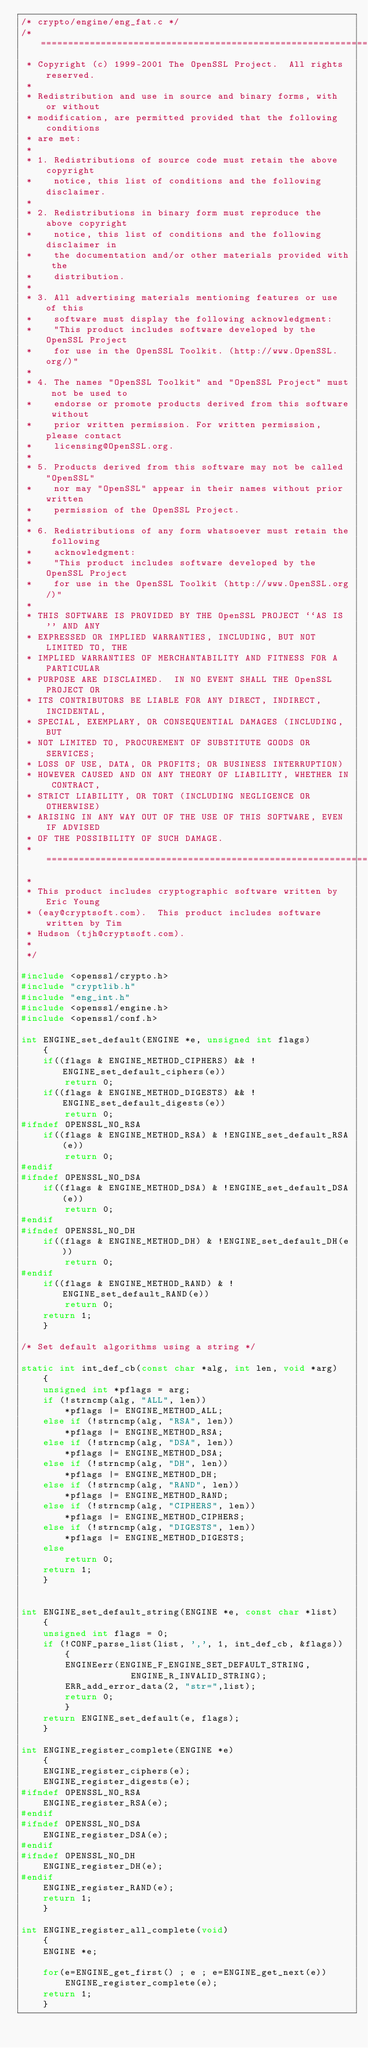Convert code to text. <code><loc_0><loc_0><loc_500><loc_500><_C_>/* crypto/engine/eng_fat.c */
/* ====================================================================
 * Copyright (c) 1999-2001 The OpenSSL Project.  All rights reserved.
 *
 * Redistribution and use in source and binary forms, with or without
 * modification, are permitted provided that the following conditions
 * are met:
 *
 * 1. Redistributions of source code must retain the above copyright
 *    notice, this list of conditions and the following disclaimer. 
 *
 * 2. Redistributions in binary form must reproduce the above copyright
 *    notice, this list of conditions and the following disclaimer in
 *    the documentation and/or other materials provided with the
 *    distribution.
 *
 * 3. All advertising materials mentioning features or use of this
 *    software must display the following acknowledgment:
 *    "This product includes software developed by the OpenSSL Project
 *    for use in the OpenSSL Toolkit. (http://www.OpenSSL.org/)"
 *
 * 4. The names "OpenSSL Toolkit" and "OpenSSL Project" must not be used to
 *    endorse or promote products derived from this software without
 *    prior written permission. For written permission, please contact
 *    licensing@OpenSSL.org.
 *
 * 5. Products derived from this software may not be called "OpenSSL"
 *    nor may "OpenSSL" appear in their names without prior written
 *    permission of the OpenSSL Project.
 *
 * 6. Redistributions of any form whatsoever must retain the following
 *    acknowledgment:
 *    "This product includes software developed by the OpenSSL Project
 *    for use in the OpenSSL Toolkit (http://www.OpenSSL.org/)"
 *
 * THIS SOFTWARE IS PROVIDED BY THE OpenSSL PROJECT ``AS IS'' AND ANY
 * EXPRESSED OR IMPLIED WARRANTIES, INCLUDING, BUT NOT LIMITED TO, THE
 * IMPLIED WARRANTIES OF MERCHANTABILITY AND FITNESS FOR A PARTICULAR
 * PURPOSE ARE DISCLAIMED.  IN NO EVENT SHALL THE OpenSSL PROJECT OR
 * ITS CONTRIBUTORS BE LIABLE FOR ANY DIRECT, INDIRECT, INCIDENTAL,
 * SPECIAL, EXEMPLARY, OR CONSEQUENTIAL DAMAGES (INCLUDING, BUT
 * NOT LIMITED TO, PROCUREMENT OF SUBSTITUTE GOODS OR SERVICES;
 * LOSS OF USE, DATA, OR PROFITS; OR BUSINESS INTERRUPTION)
 * HOWEVER CAUSED AND ON ANY THEORY OF LIABILITY, WHETHER IN CONTRACT,
 * STRICT LIABILITY, OR TORT (INCLUDING NEGLIGENCE OR OTHERWISE)
 * ARISING IN ANY WAY OUT OF THE USE OF THIS SOFTWARE, EVEN IF ADVISED
 * OF THE POSSIBILITY OF SUCH DAMAGE.
 * ====================================================================
 *
 * This product includes cryptographic software written by Eric Young
 * (eay@cryptsoft.com).  This product includes software written by Tim
 * Hudson (tjh@cryptsoft.com).
 *
 */

#include <openssl/crypto.h>
#include "cryptlib.h"
#include "eng_int.h"
#include <openssl/engine.h>
#include <openssl/conf.h>

int ENGINE_set_default(ENGINE *e, unsigned int flags)
	{
	if((flags & ENGINE_METHOD_CIPHERS) && !ENGINE_set_default_ciphers(e))
		return 0;
	if((flags & ENGINE_METHOD_DIGESTS) && !ENGINE_set_default_digests(e))
		return 0;
#ifndef OPENSSL_NO_RSA
	if((flags & ENGINE_METHOD_RSA) & !ENGINE_set_default_RSA(e))
		return 0;
#endif
#ifndef OPENSSL_NO_DSA
	if((flags & ENGINE_METHOD_DSA) & !ENGINE_set_default_DSA(e))
		return 0;
#endif
#ifndef OPENSSL_NO_DH
	if((flags & ENGINE_METHOD_DH) & !ENGINE_set_default_DH(e))
		return 0;
#endif
	if((flags & ENGINE_METHOD_RAND) & !ENGINE_set_default_RAND(e))
		return 0;
	return 1;
	}

/* Set default algorithms using a string */

static int int_def_cb(const char *alg, int len, void *arg)
	{
	unsigned int *pflags = arg;
	if (!strncmp(alg, "ALL", len))
		*pflags |= ENGINE_METHOD_ALL;
	else if (!strncmp(alg, "RSA", len))
		*pflags |= ENGINE_METHOD_RSA;
	else if (!strncmp(alg, "DSA", len))
		*pflags |= ENGINE_METHOD_DSA;
	else if (!strncmp(alg, "DH", len))
		*pflags |= ENGINE_METHOD_DH;
	else if (!strncmp(alg, "RAND", len))
		*pflags |= ENGINE_METHOD_RAND;
	else if (!strncmp(alg, "CIPHERS", len))
		*pflags |= ENGINE_METHOD_CIPHERS;
	else if (!strncmp(alg, "DIGESTS", len))
		*pflags |= ENGINE_METHOD_DIGESTS;
	else
		return 0;
	return 1;
	}


int ENGINE_set_default_string(ENGINE *e, const char *list)
	{
	unsigned int flags = 0;
	if (!CONF_parse_list(list, ',', 1, int_def_cb, &flags))
		{
		ENGINEerr(ENGINE_F_ENGINE_SET_DEFAULT_STRING,
					ENGINE_R_INVALID_STRING);
		ERR_add_error_data(2, "str=",list);
		return 0;
		}
	return ENGINE_set_default(e, flags);
	}

int ENGINE_register_complete(ENGINE *e)
	{
	ENGINE_register_ciphers(e);
	ENGINE_register_digests(e);
#ifndef OPENSSL_NO_RSA
	ENGINE_register_RSA(e);
#endif
#ifndef OPENSSL_NO_DSA
	ENGINE_register_DSA(e);
#endif
#ifndef OPENSSL_NO_DH
	ENGINE_register_DH(e);
#endif
	ENGINE_register_RAND(e);
	return 1;
	}

int ENGINE_register_all_complete(void)
	{
	ENGINE *e;

	for(e=ENGINE_get_first() ; e ; e=ENGINE_get_next(e))
		ENGINE_register_complete(e);
	return 1;
	}
</code> 